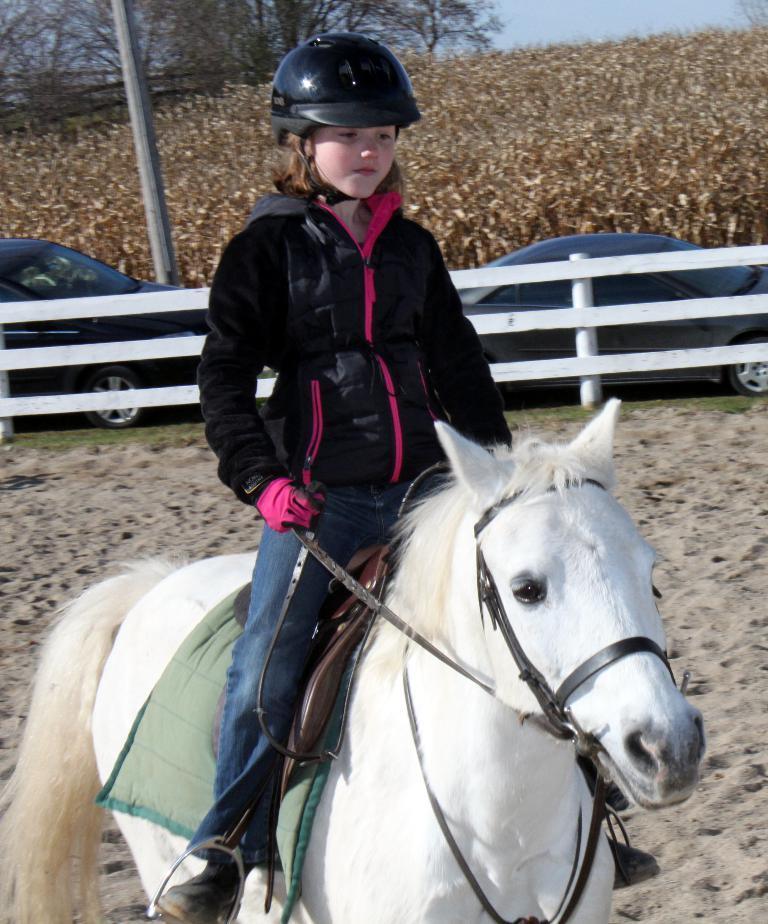Could you give a brief overview of what you see in this image? In this image I can see a girl wearing a black color jacket and black color helmet ,sitting on horse and the horse color is white at the top I can see grass and the sky,tree,fence and pole and vehicle. 